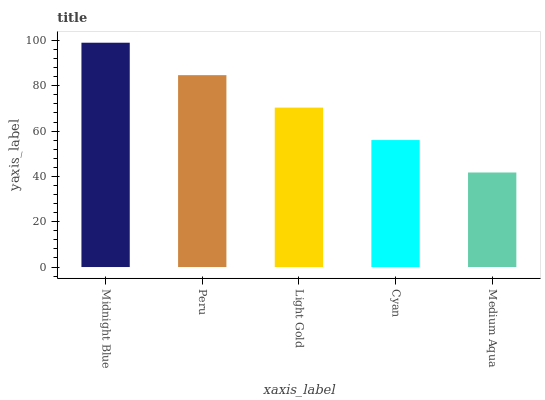Is Medium Aqua the minimum?
Answer yes or no. Yes. Is Midnight Blue the maximum?
Answer yes or no. Yes. Is Peru the minimum?
Answer yes or no. No. Is Peru the maximum?
Answer yes or no. No. Is Midnight Blue greater than Peru?
Answer yes or no. Yes. Is Peru less than Midnight Blue?
Answer yes or no. Yes. Is Peru greater than Midnight Blue?
Answer yes or no. No. Is Midnight Blue less than Peru?
Answer yes or no. No. Is Light Gold the high median?
Answer yes or no. Yes. Is Light Gold the low median?
Answer yes or no. Yes. Is Peru the high median?
Answer yes or no. No. Is Cyan the low median?
Answer yes or no. No. 